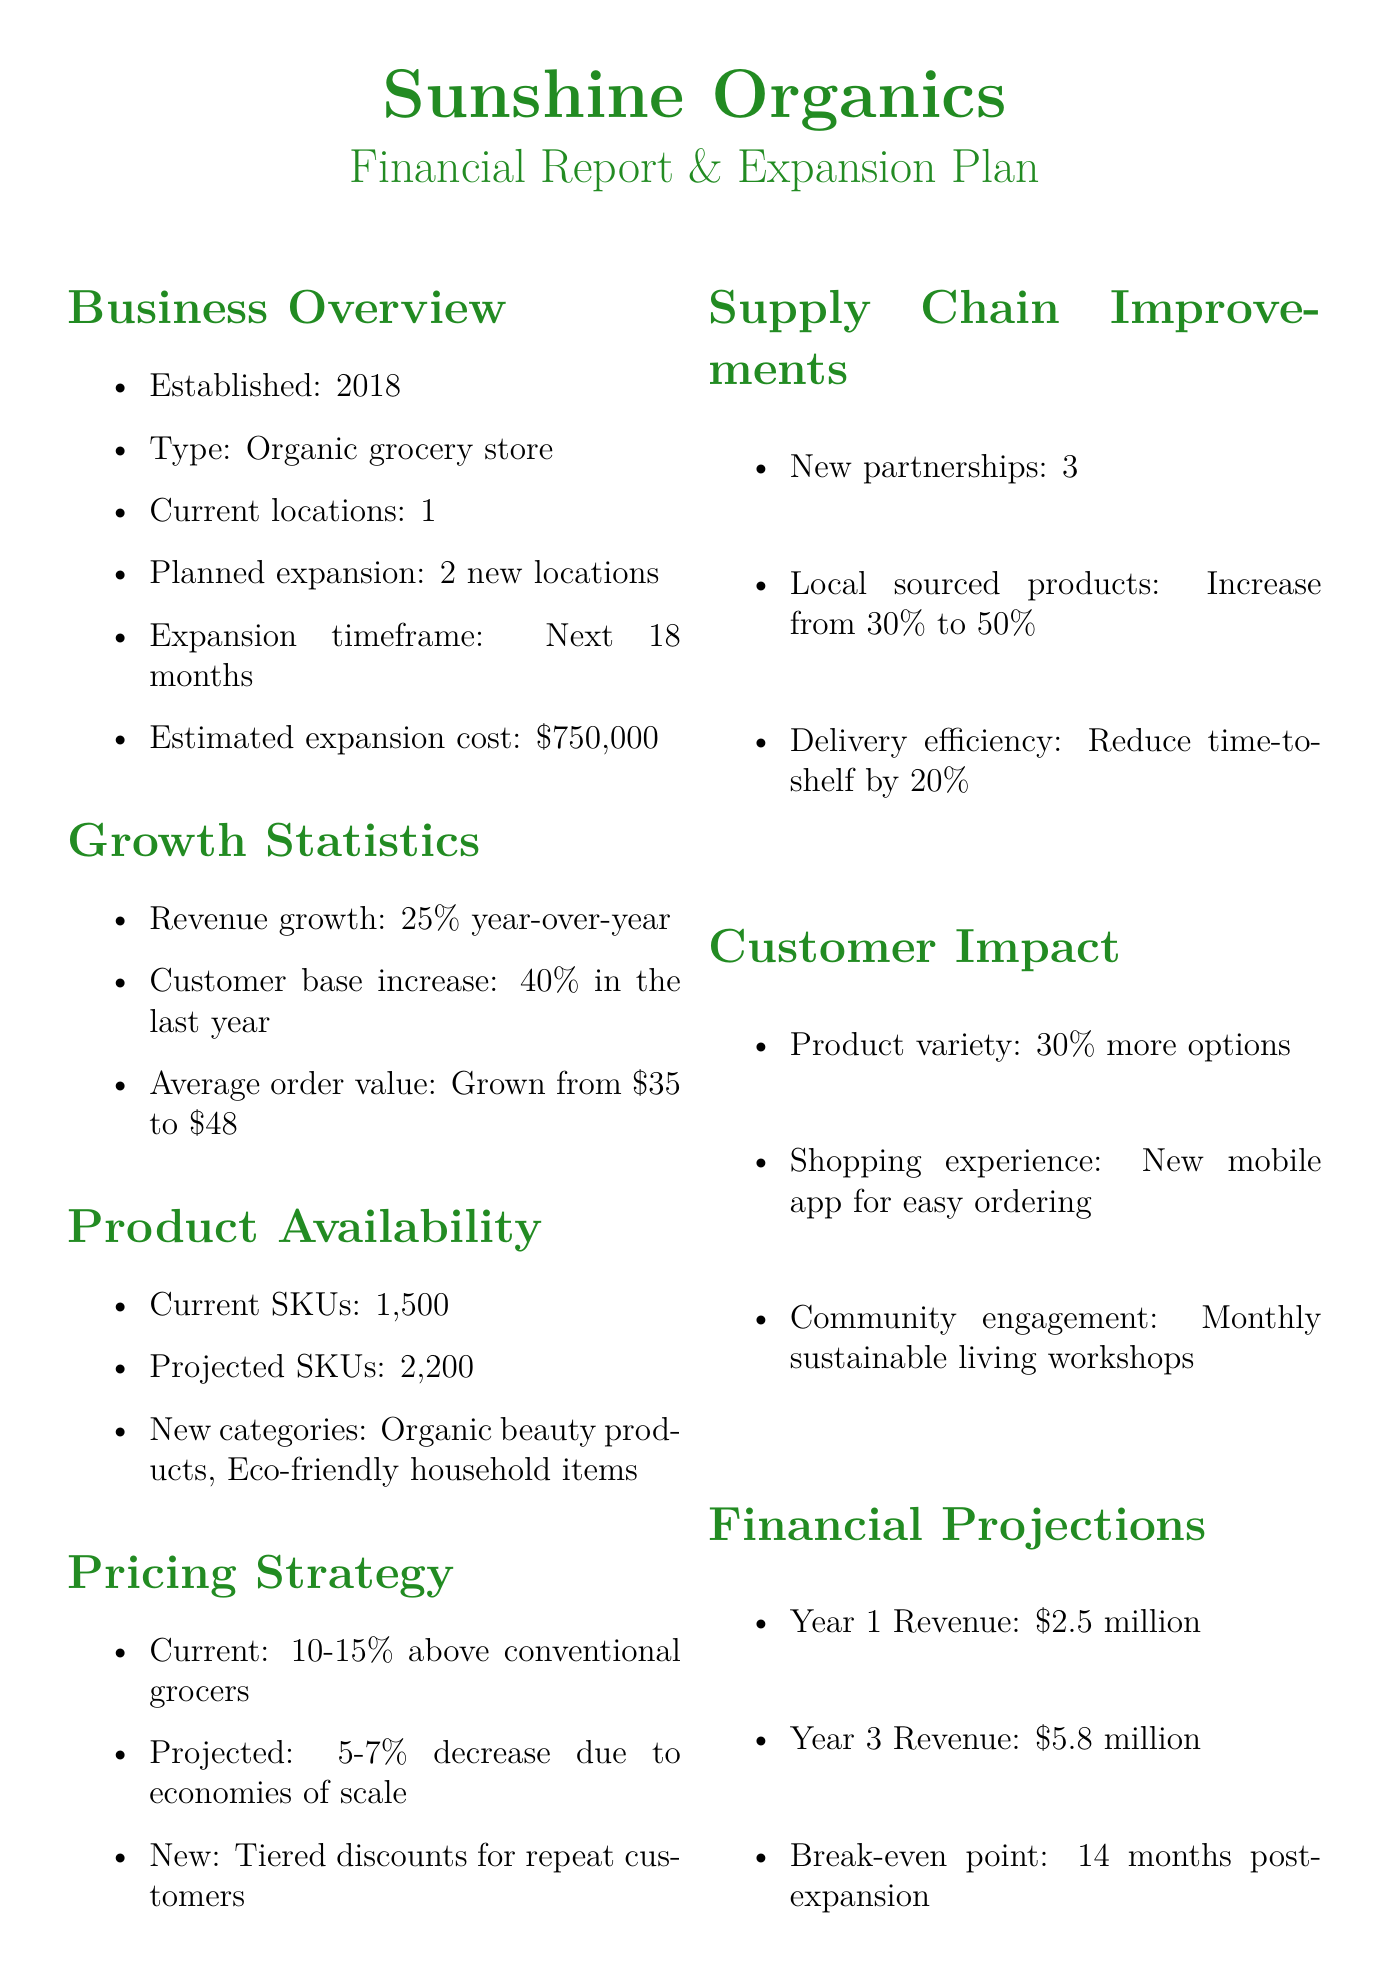What is the name of the business? The name of the business is mentioned at the beginning of the document.
Answer: Sunshine Organics What year was the business established? The year of establishment is specified in the business overview section.
Answer: 2018 How many new locations are planned? The planned new locations are outlined in the expansion plan.
Answer: 2 What is the estimated cost of the expansion? The estimated cost for the expansion is mentioned in the planned expansion section.
Answer: $750,000 What is the average order value now? The average order value is noted in the growth statistics section of the document.
Answer: Grown from $35 to $48 What is the current price point above conventional grocers? The current price point is indicated in the pricing strategy section.
Answer: 10-15% What is the projected revenue in year 3? The revenue projection for year 3 is specified in the financial projections section.
Answer: $5.8 million How much will local sourced products increase? The increase in locally sourced products is detailed in the supply chain improvements section.
Answer: Increase from 30% to 50% What new categories are being introduced? The new categories being introduced are listed in the product availability section.
Answer: Organic beauty products, Eco-friendly household items What type of app is being introduced? The type of app being introduced is mentioned in the customer impact section.
Answer: Mobile app for easy ordering 